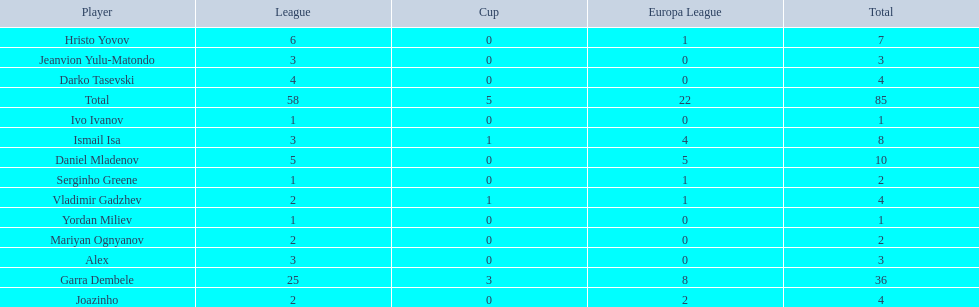What is the difference between vladimir gadzhev and yordan miliev's scores? 3. Write the full table. {'header': ['Player', 'League', 'Cup', 'Europa League', 'Total'], 'rows': [['Hristo Yovov', '6', '0', '1', '7'], ['Jeanvion Yulu-Matondo', '3', '0', '0', '3'], ['Darko Tasevski', '4', '0', '0', '4'], ['Total', '58', '5', '22', '85'], ['Ivo Ivanov', '1', '0', '0', '1'], ['Ismail Isa', '3', '1', '4', '8'], ['Daniel Mladenov', '5', '0', '5', '10'], ['Serginho Greene', '1', '0', '1', '2'], ['Vladimir Gadzhev', '2', '1', '1', '4'], ['Yordan Miliev', '1', '0', '0', '1'], ['Mariyan Ognyanov', '2', '0', '0', '2'], ['Alex', '3', '0', '0', '3'], ['Garra Dembele', '25', '3', '8', '36'], ['Joazinho', '2', '0', '2', '4']]} 